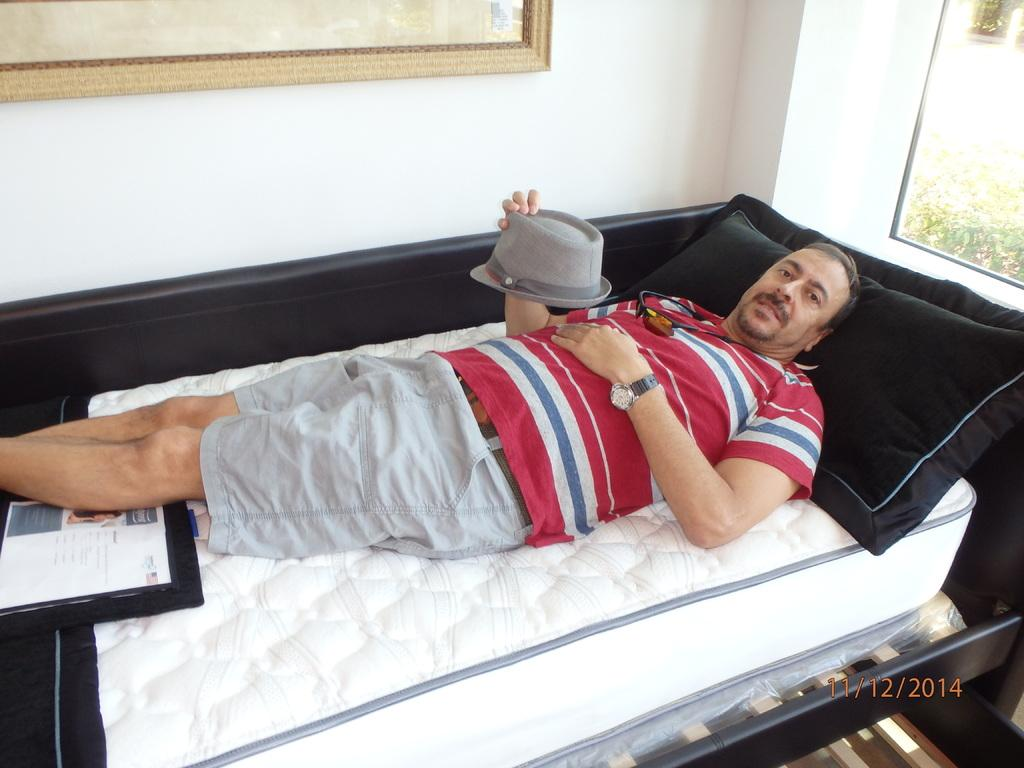Who is present in the image? There is a man in the image. What is the man doing in the image? The man is sleeping on the bed. What is the man holding in his hand? The man is holding a cap in his hand. What is supporting the man's head while he sleeps? There is a pillow under the man's head. What can be seen in the background of the image? There is a wall in the background of the image, and there is a frame on the wall. What type of bean is visible on the man's plate in the image? There is no bean visible in the image; the man is sleeping on the bed and not eating. 